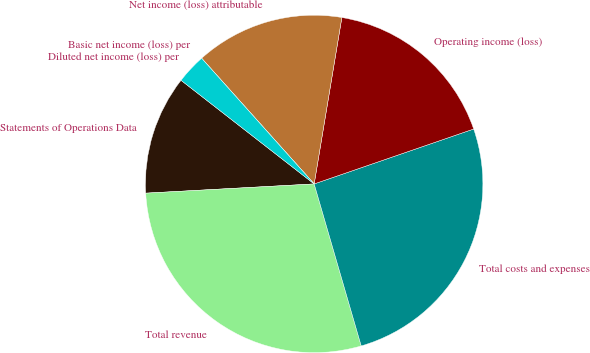Convert chart to OTSL. <chart><loc_0><loc_0><loc_500><loc_500><pie_chart><fcel>Statements of Operations Data<fcel>Total revenue<fcel>Total costs and expenses<fcel>Operating income (loss)<fcel>Net income (loss) attributable<fcel>Basic net income (loss) per<fcel>Diluted net income (loss) per<nl><fcel>11.4%<fcel>28.63%<fcel>25.78%<fcel>17.1%<fcel>14.25%<fcel>0.0%<fcel>2.85%<nl></chart> 